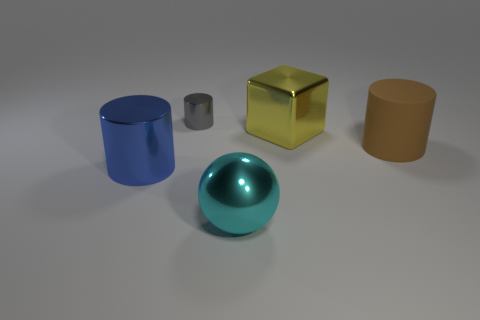Subtract all balls. How many objects are left? 4 Add 2 small gray cylinders. How many objects exist? 7 Add 5 large yellow shiny blocks. How many large yellow shiny blocks are left? 6 Add 3 shiny cubes. How many shiny cubes exist? 4 Subtract 1 gray cylinders. How many objects are left? 4 Subtract all small gray shiny cylinders. Subtract all blocks. How many objects are left? 3 